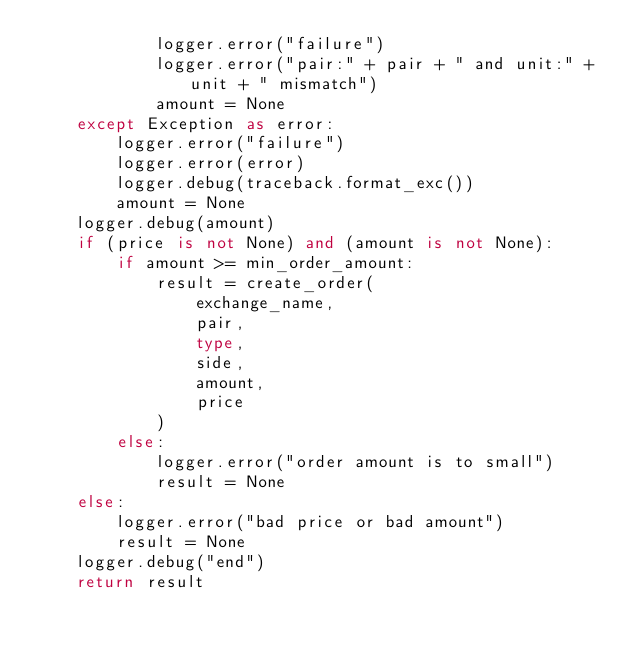<code> <loc_0><loc_0><loc_500><loc_500><_Python_>            logger.error("failure")
            logger.error("pair:" + pair + " and unit:" + unit + " mismatch")
            amount = None
    except Exception as error:
        logger.error("failure")
        logger.error(error)
        logger.debug(traceback.format_exc())
        amount = None
    logger.debug(amount)
    if (price is not None) and (amount is not None):
        if amount >= min_order_amount:
            result = create_order(
                exchange_name,
                pair,
                type,
                side,
                amount,
                price
            )
        else:
            logger.error("order amount is to small")
            result = None
    else:
        logger.error("bad price or bad amount")
        result = None
    logger.debug("end")
    return result
</code> 